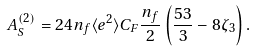<formula> <loc_0><loc_0><loc_500><loc_500>A _ { S } ^ { ( 2 ) } = 2 4 n _ { f } \langle e ^ { 2 } \rangle C _ { F } \frac { n _ { f } } { 2 } \left ( \frac { 5 3 } { 3 } - 8 \zeta _ { 3 } \right ) .</formula> 